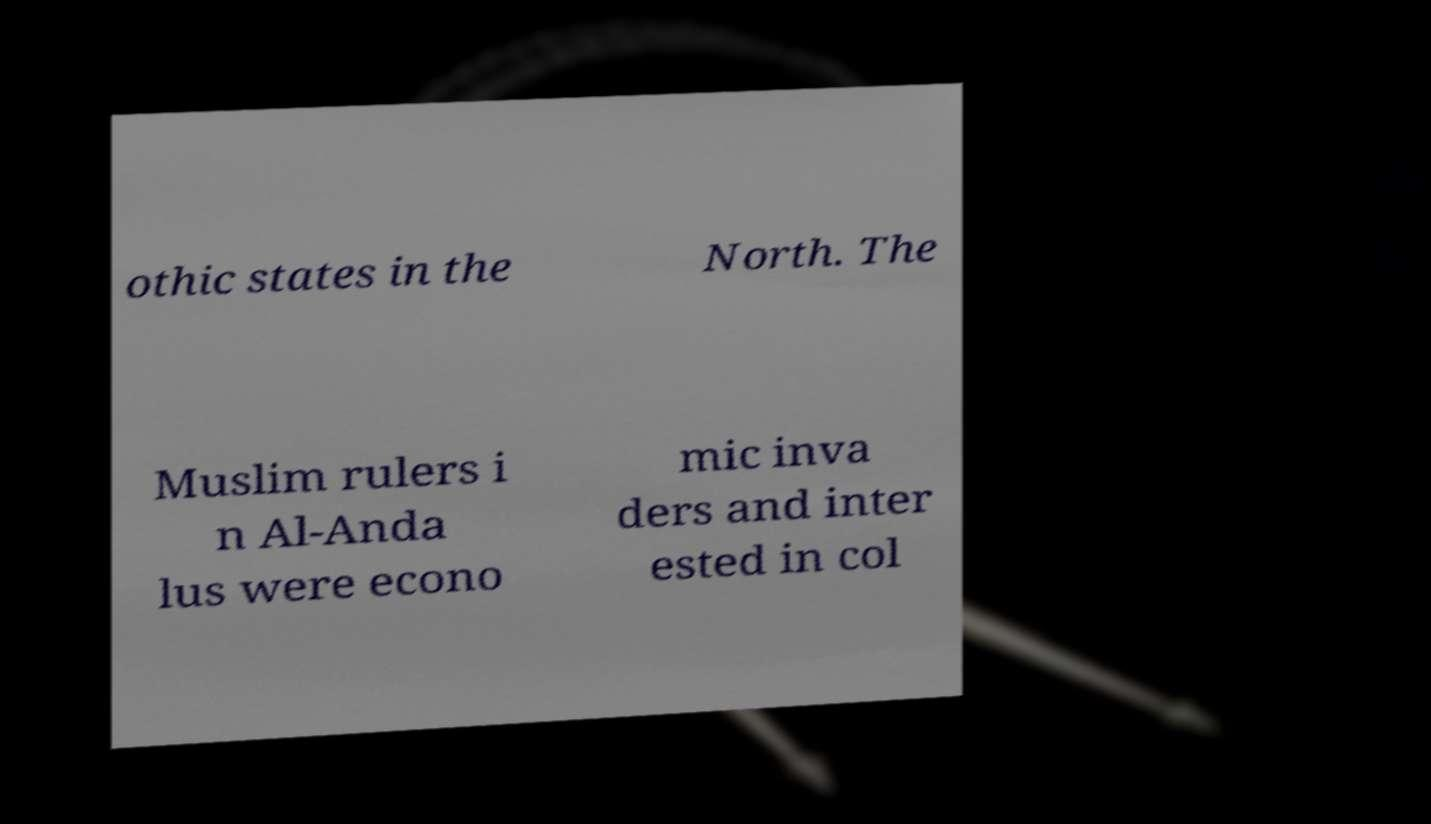There's text embedded in this image that I need extracted. Can you transcribe it verbatim? othic states in the North. The Muslim rulers i n Al-Anda lus were econo mic inva ders and inter ested in col 